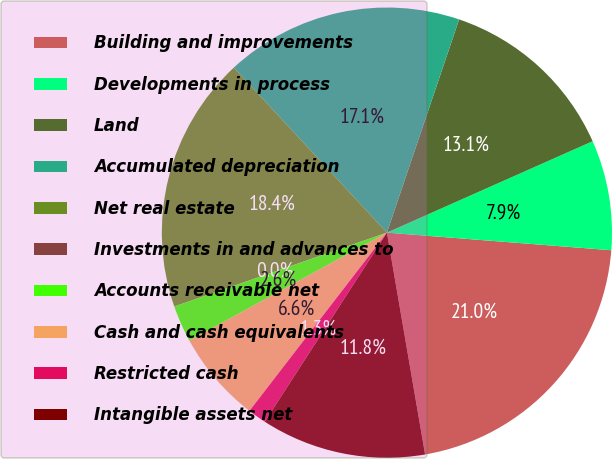Convert chart to OTSL. <chart><loc_0><loc_0><loc_500><loc_500><pie_chart><fcel>Building and improvements<fcel>Developments in process<fcel>Land<fcel>Accumulated depreciation<fcel>Net real estate<fcel>Investments in and advances to<fcel>Accounts receivable net<fcel>Cash and cash equivalents<fcel>Restricted cash<fcel>Intangible assets net<nl><fcel>21.04%<fcel>7.9%<fcel>13.15%<fcel>17.1%<fcel>18.41%<fcel>0.01%<fcel>2.64%<fcel>6.58%<fcel>1.33%<fcel>11.84%<nl></chart> 